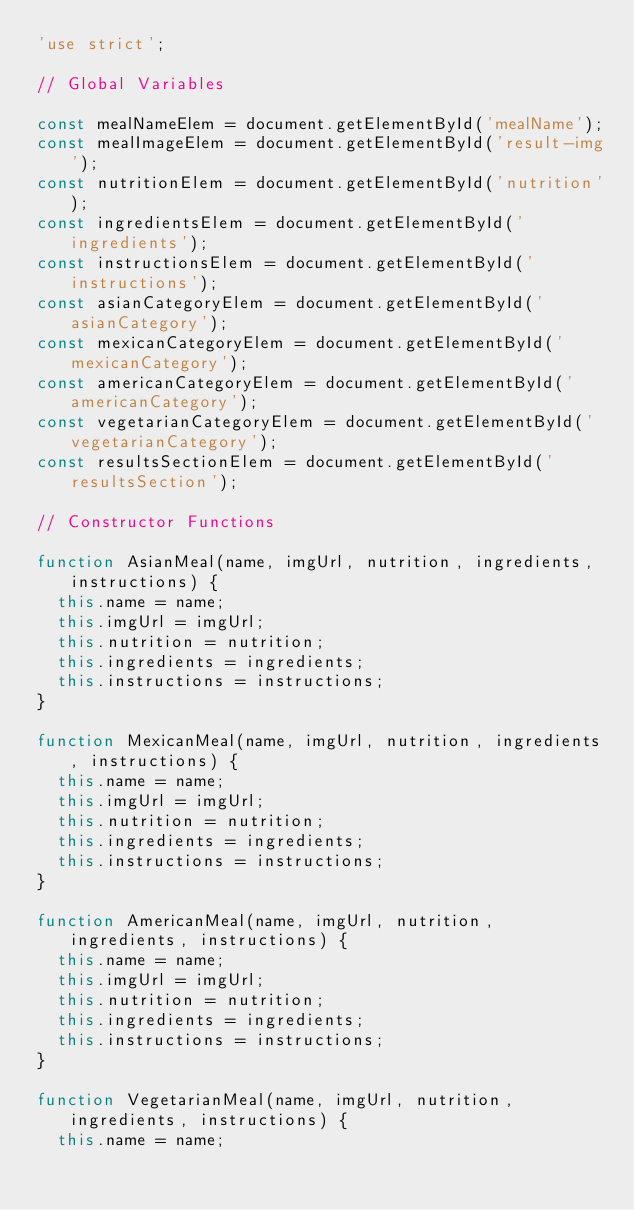Convert code to text. <code><loc_0><loc_0><loc_500><loc_500><_JavaScript_>'use strict';

// Global Variables 

const mealNameElem = document.getElementById('mealName');
const mealImageElem = document.getElementById('result-img');
const nutritionElem = document.getElementById('nutrition');
const ingredientsElem = document.getElementById('ingredients');
const instructionsElem = document.getElementById('instructions');
const asianCategoryElem = document.getElementById('asianCategory');
const mexicanCategoryElem = document.getElementById('mexicanCategory');
const americanCategoryElem = document.getElementById('americanCategory');
const vegetarianCategoryElem = document.getElementById('vegetarianCategory');
const resultsSectionElem = document.getElementById('resultsSection');

// Constructor Functions

function AsianMeal(name, imgUrl, nutrition, ingredients, instructions) {
  this.name = name;
  this.imgUrl = imgUrl;
  this.nutrition = nutrition;
  this.ingredients = ingredients;
  this.instructions = instructions;
}

function MexicanMeal(name, imgUrl, nutrition, ingredients, instructions) {
  this.name = name;
  this.imgUrl = imgUrl;
  this.nutrition = nutrition;
  this.ingredients = ingredients;
  this.instructions = instructions;
}

function AmericanMeal(name, imgUrl, nutrition, ingredients, instructions) {
  this.name = name;
  this.imgUrl = imgUrl;
  this.nutrition = nutrition;
  this.ingredients = ingredients;
  this.instructions = instructions;
}

function VegetarianMeal(name, imgUrl, nutrition, ingredients, instructions) {
  this.name = name;</code> 